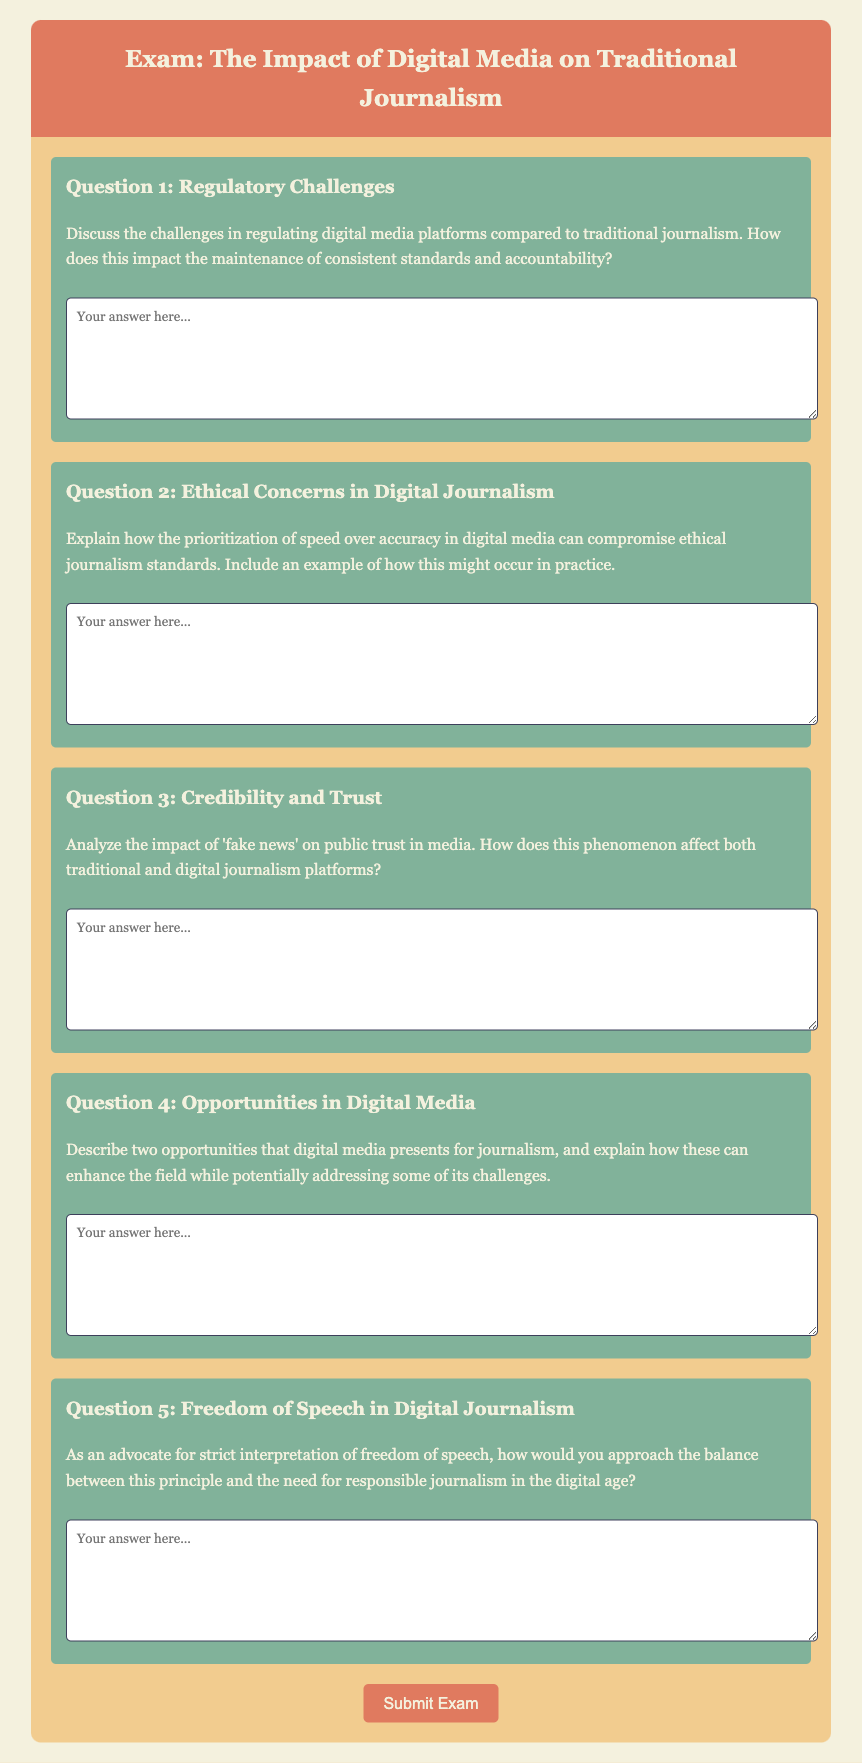What is the title of the exam? The title of the exam is stated in the header section of the document.
Answer: Digital Media Impact on Journalism Exam How many questions are in the exam? By counting the number of distinct question sections within the document, the total can be determined.
Answer: 5 What is Question 2 about? Question 2's heading reveals its focus on ethical issues related to digital media.
Answer: Ethical Concerns in Digital Journalism What style is the font used in the document? The document specifies the font type used for the body of the text in the CSS section.
Answer: Georgia What color is the background of the header? The document specifies background colors for different sections in the CSS styling.
Answer: #e07a5f In Question 3, what phenomenon is mentioned that impacts public trust? The discussion in Question 3 references a specific type of information that affects trust in the media.
Answer: Fake news What is the required format for answers in the exam? The document indicates how users are to respond to questions by providing a specific input area.
Answer: Textarea What opportunities does Question 4 ask about? Question 4 directly asks for a specific aspect of digital media and journalism.
Answer: Two opportunities What does Question 5 address regarding journalism? The content of Question 5 focuses on a specific principle within the context of journalism.
Answer: Freedom of Speech What is the color of the submit button? The color of the submit button is specified within the CSS styles for that element.
Answer: #e07a5f 